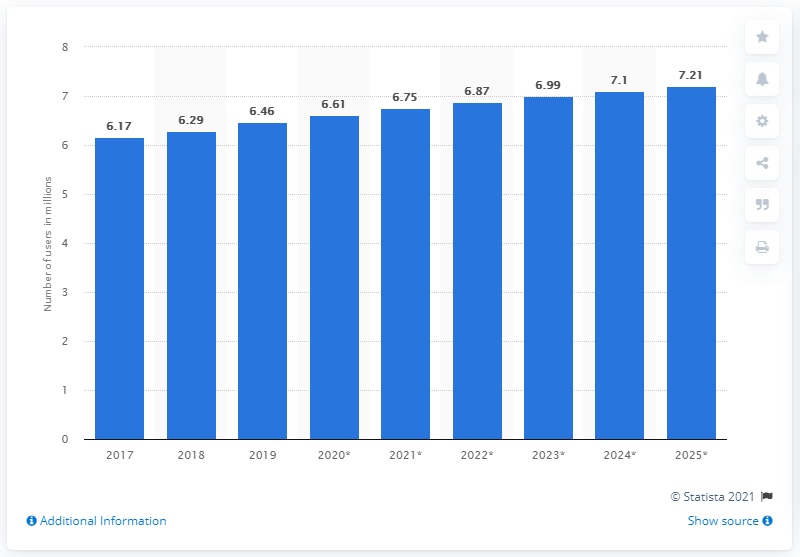Indicate a few pertinent items in this graphic. In 2019, there were approximately 6.46 million Facebook users in Hong Kong. By 2025, it was projected that there would be 7.21 million Facebook users in Hong Kong. 